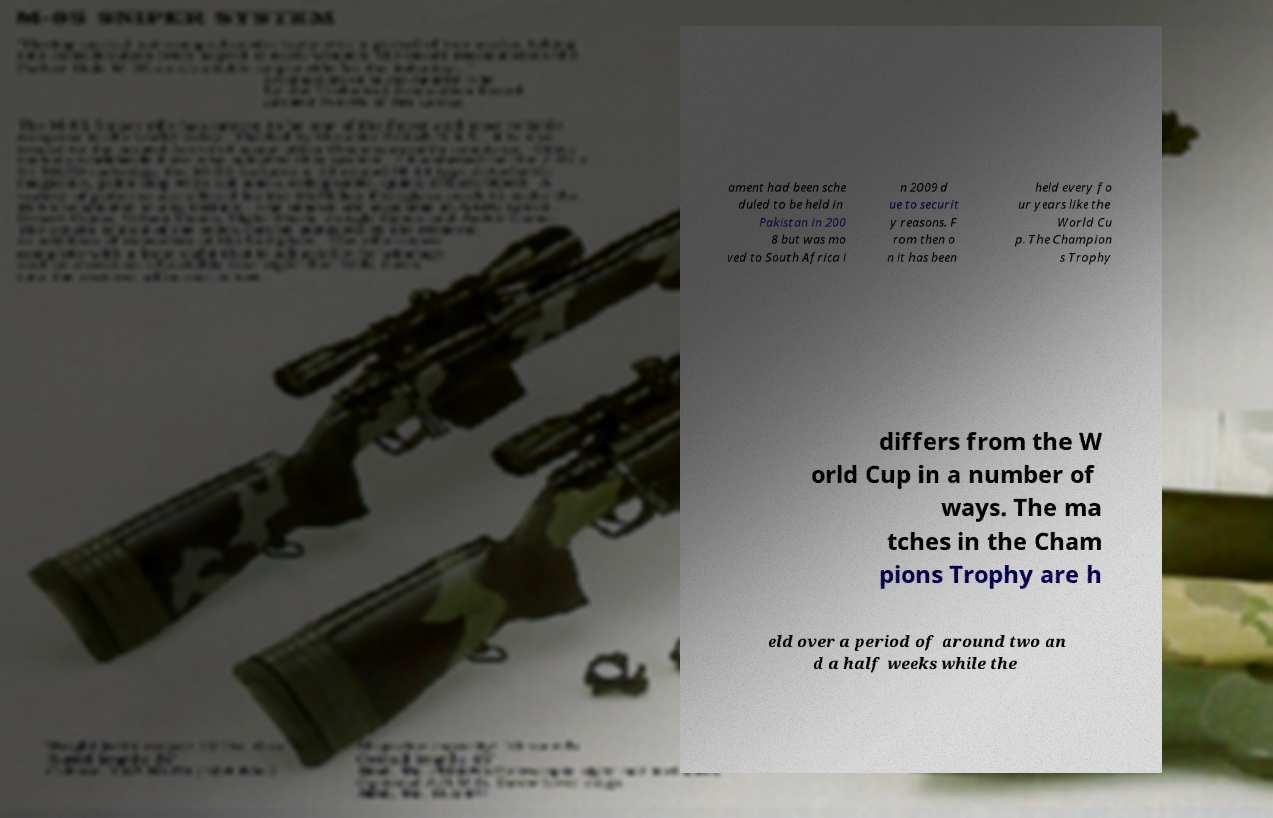Can you accurately transcribe the text from the provided image for me? ament had been sche duled to be held in Pakistan in 200 8 but was mo ved to South Africa i n 2009 d ue to securit y reasons. F rom then o n it has been held every fo ur years like the World Cu p. The Champion s Trophy differs from the W orld Cup in a number of ways. The ma tches in the Cham pions Trophy are h eld over a period of around two an d a half weeks while the 